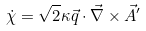<formula> <loc_0><loc_0><loc_500><loc_500>\dot { \chi } = \sqrt { 2 } \kappa \vec { q } \cdot \vec { \nabla } \times \vec { A } ^ { \prime }</formula> 